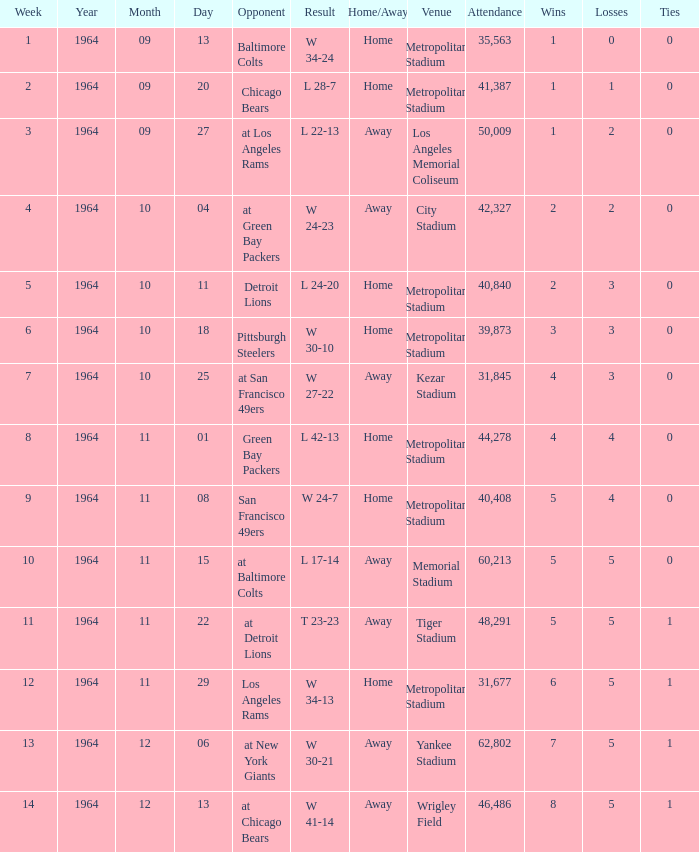What is the result when the record was 1-0 and it was earlier than week 4? W 34-24. 